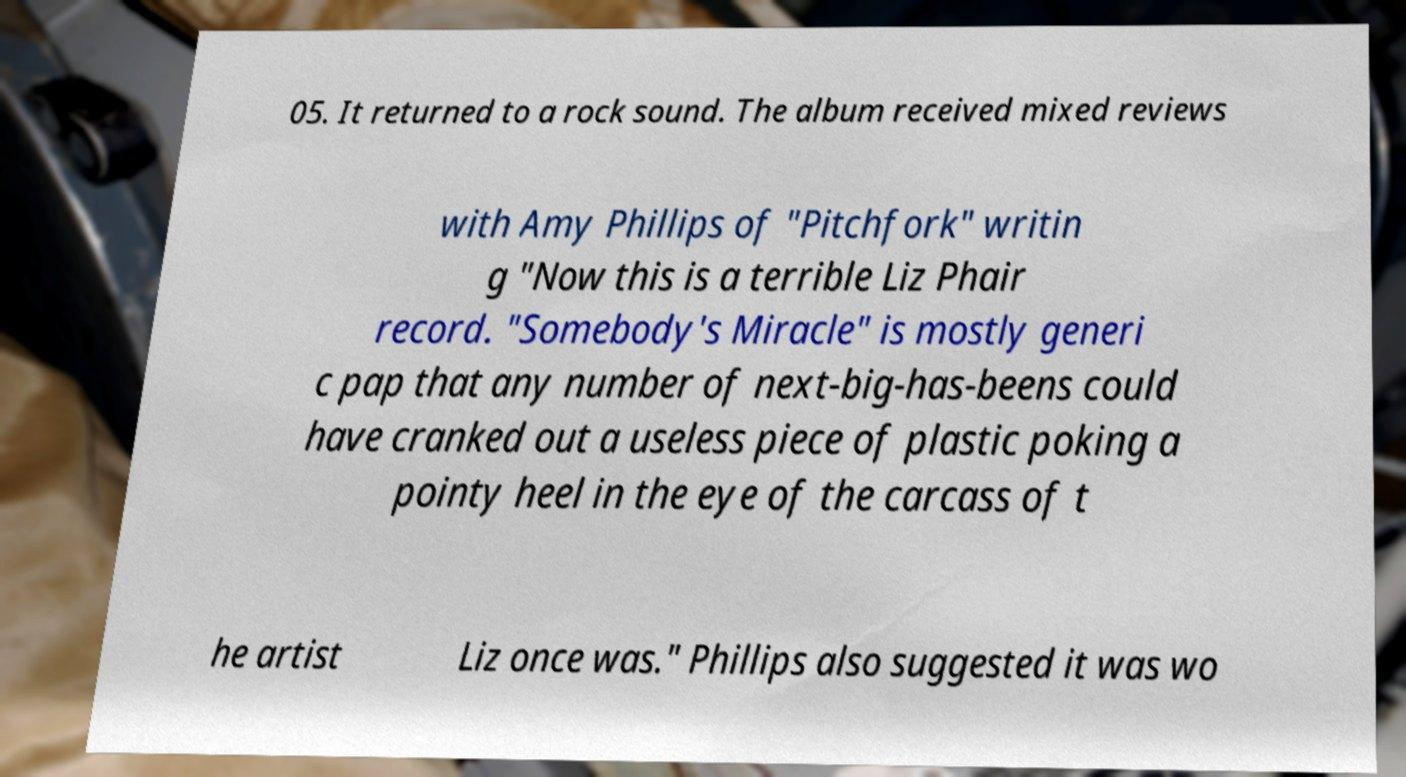Please identify and transcribe the text found in this image. 05. It returned to a rock sound. The album received mixed reviews with Amy Phillips of "Pitchfork" writin g "Now this is a terrible Liz Phair record. "Somebody's Miracle" is mostly generi c pap that any number of next-big-has-beens could have cranked out a useless piece of plastic poking a pointy heel in the eye of the carcass of t he artist Liz once was." Phillips also suggested it was wo 